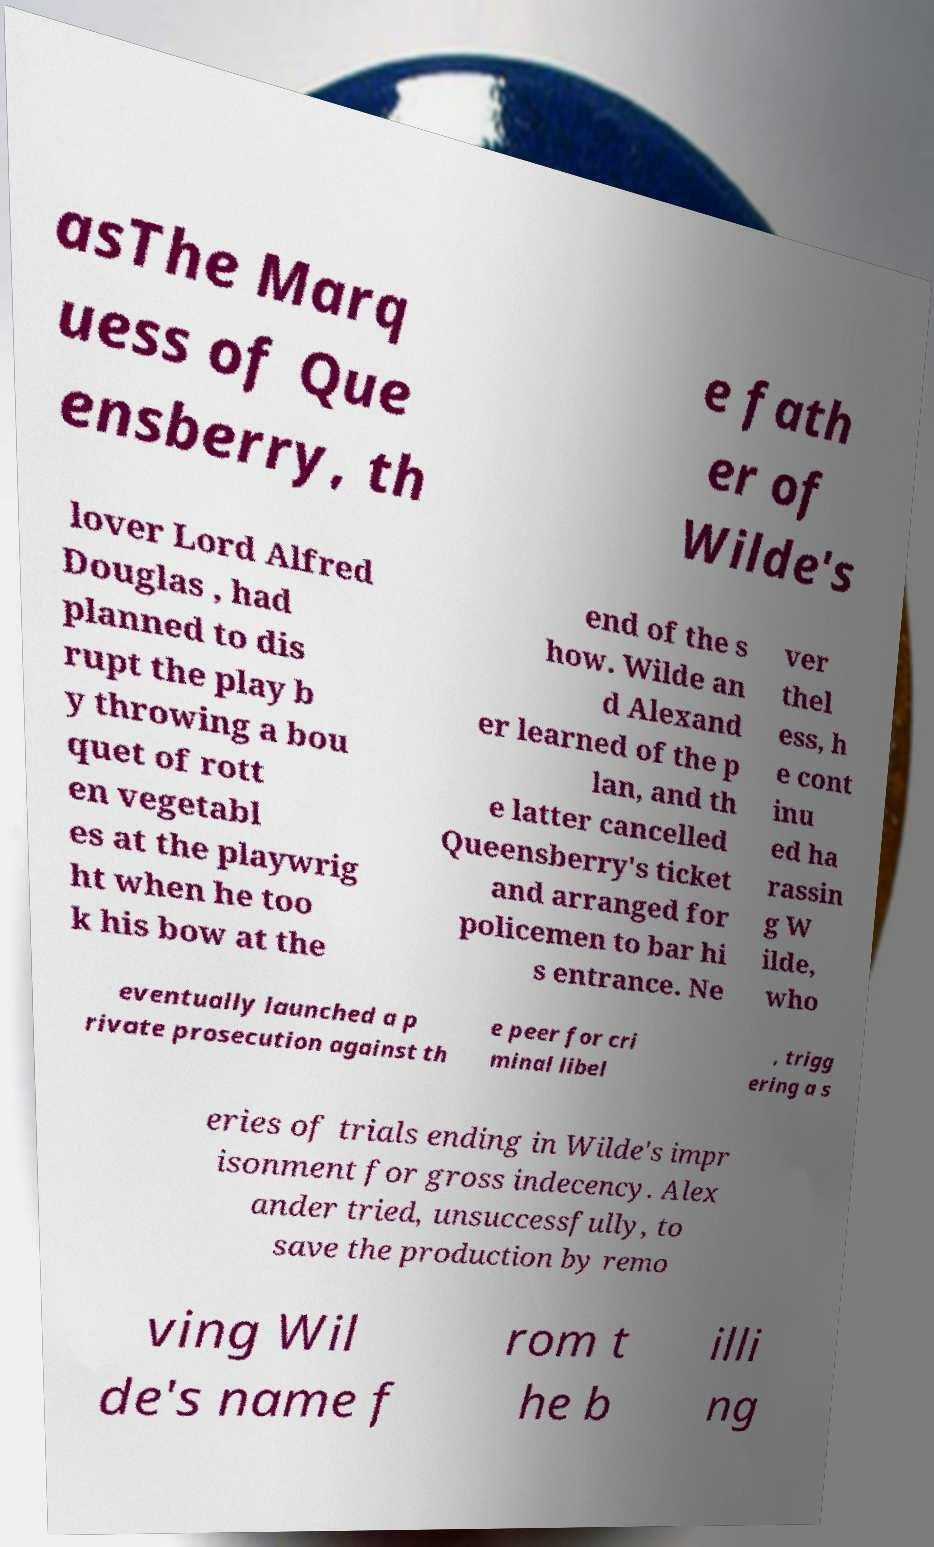Please read and relay the text visible in this image. What does it say? asThe Marq uess of Que ensberry, th e fath er of Wilde's lover Lord Alfred Douglas , had planned to dis rupt the play b y throwing a bou quet of rott en vegetabl es at the playwrig ht when he too k his bow at the end of the s how. Wilde an d Alexand er learned of the p lan, and th e latter cancelled Queensberry's ticket and arranged for policemen to bar hi s entrance. Ne ver thel ess, h e cont inu ed ha rassin g W ilde, who eventually launched a p rivate prosecution against th e peer for cri minal libel , trigg ering a s eries of trials ending in Wilde's impr isonment for gross indecency. Alex ander tried, unsuccessfully, to save the production by remo ving Wil de's name f rom t he b illi ng 